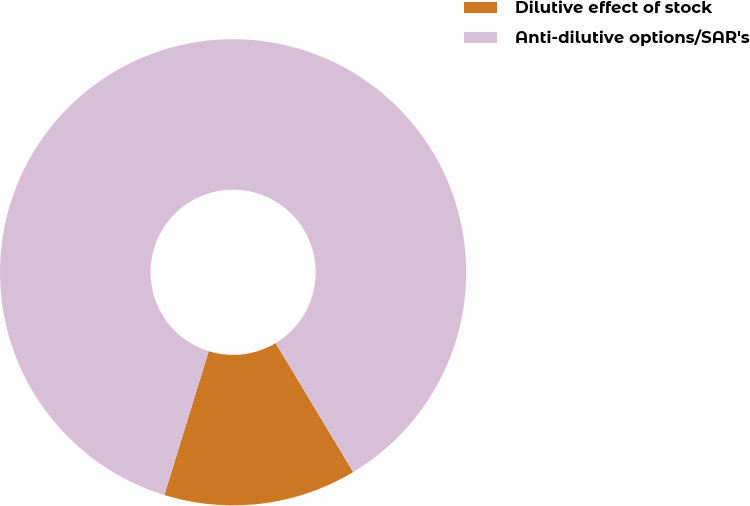<chart> <loc_0><loc_0><loc_500><loc_500><pie_chart><fcel>Dilutive effect of stock<fcel>Anti-dilutive options/SAR's<nl><fcel>13.38%<fcel>86.62%<nl></chart> 